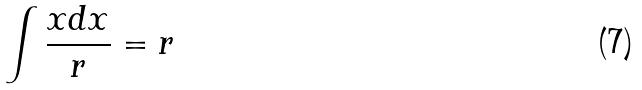Convert formula to latex. <formula><loc_0><loc_0><loc_500><loc_500>\int \frac { x d x } { r } = r</formula> 